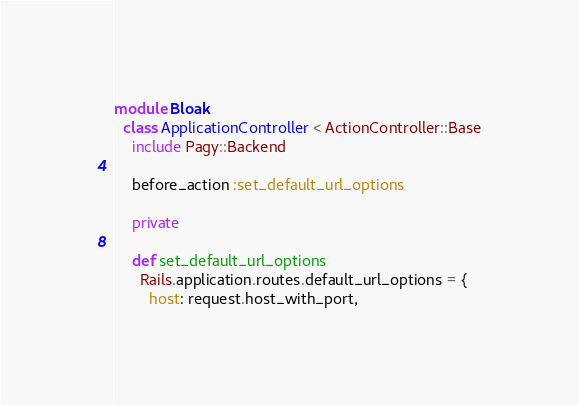Convert code to text. <code><loc_0><loc_0><loc_500><loc_500><_Ruby_>module Bloak
  class ApplicationController < ActionController::Base
    include Pagy::Backend

    before_action :set_default_url_options

    private

    def set_default_url_options
      Rails.application.routes.default_url_options = {
        host: request.host_with_port,</code> 